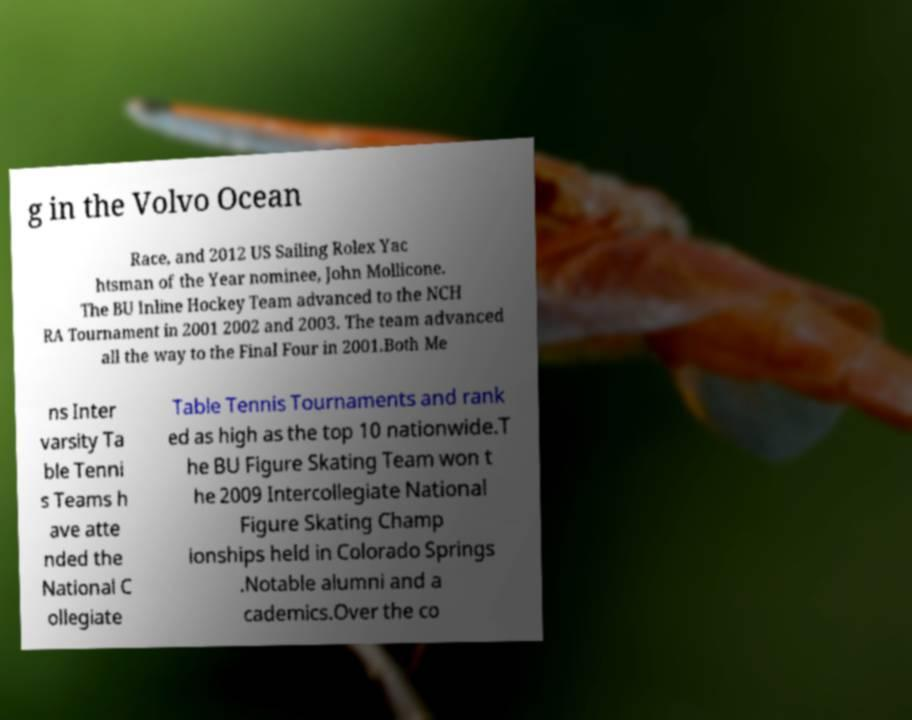Can you read and provide the text displayed in the image?This photo seems to have some interesting text. Can you extract and type it out for me? g in the Volvo Ocean Race, and 2012 US Sailing Rolex Yac htsman of the Year nominee, John Mollicone. The BU Inline Hockey Team advanced to the NCH RA Tournament in 2001 2002 and 2003. The team advanced all the way to the Final Four in 2001.Both Me ns Inter varsity Ta ble Tenni s Teams h ave atte nded the National C ollegiate Table Tennis Tournaments and rank ed as high as the top 10 nationwide.T he BU Figure Skating Team won t he 2009 Intercollegiate National Figure Skating Champ ionships held in Colorado Springs .Notable alumni and a cademics.Over the co 